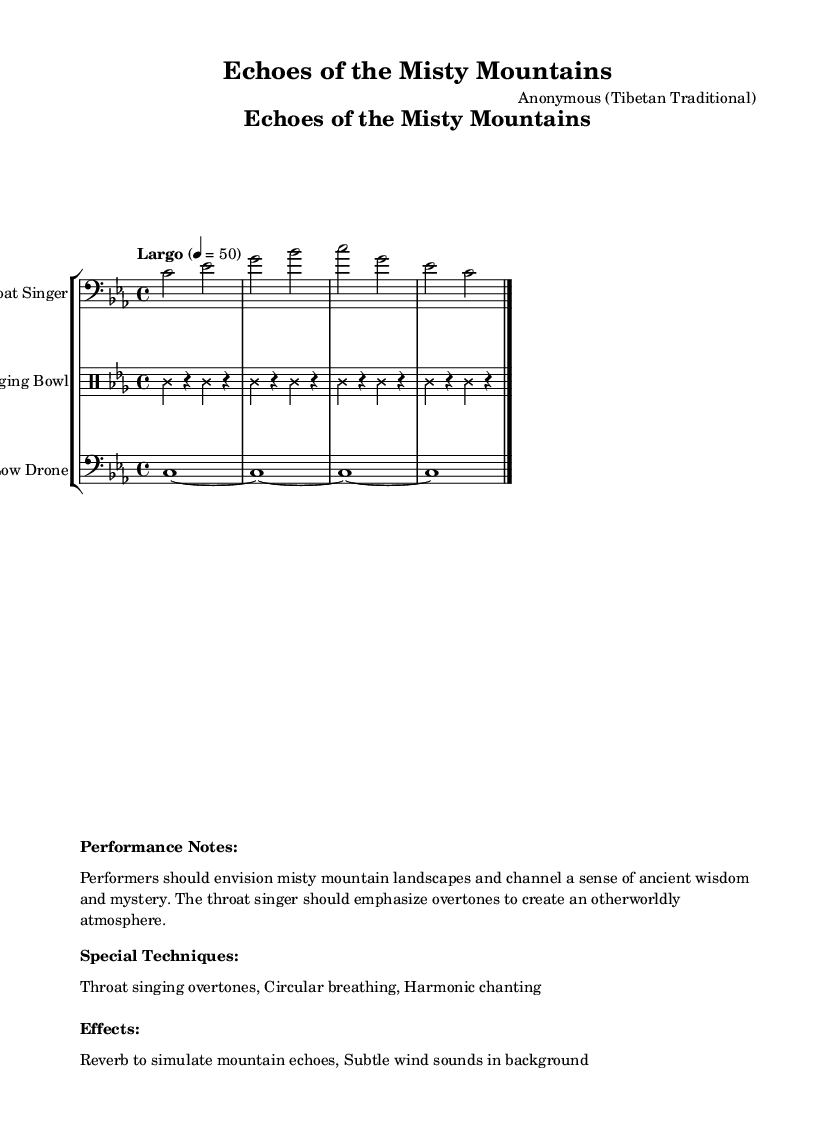What is the time signature of this music? The time signature is indicated by the notation "4/4" found at the beginning of the score. This means there are four beats in each measure and a quarter note gets one beat.
Answer: 4/4 What is the key signature of this music? The key signature is indicated by the presence of three flats (B flat, E flat, and A flat) in the music, which corresponds to C minor.
Answer: C minor What is the tempo marking given for this piece? The tempo marking is indicated by the text "Largo" followed by a metronome marking of "4 = 50". This suggests a slow tempo.
Answer: Largo How many measures are in the throat singer's part? The throat singer's part consists of four measures, as indicated by the notation throughout the section.
Answer: 4 What unique vocal technique is emphasized in the performance notes? The performance notes highlight "Throat singing overtones" as a special technique, indicating the use of unique vocal techniques specific to throat singing.
Answer: Throat singing overtones What is the primary instrument besides throat singing used in this music? The primary instrument used alongside throat singing is the Tibetan singing bowl, as indicated in the instrument list within the score.
Answer: Tibetan singing bowl What atmosphere or imagery should performers evoke according to the performance notes? The performance notes instruct performers to visualize "misty mountain landscapes", which is intended to inspire the ancient and mysterious quality of the performance.
Answer: Misty mountain landscapes 